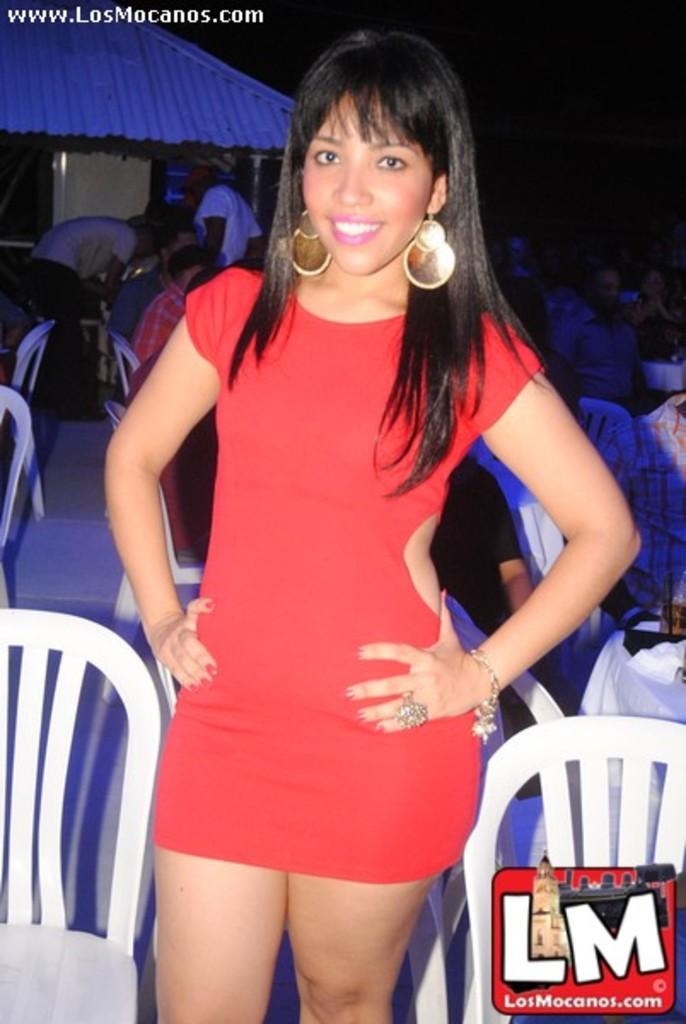<image>
Create a compact narrative representing the image presented. A lady wearing a red dress is posing for a picture for Losmocanos.com 